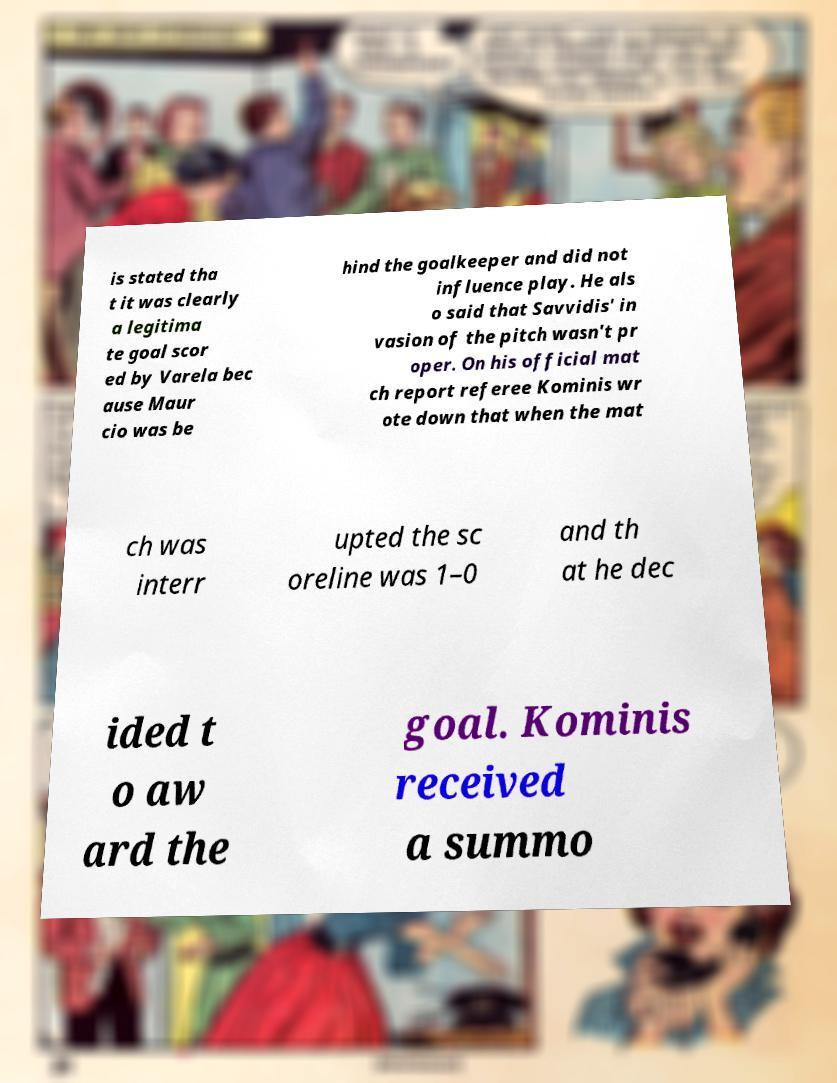What messages or text are displayed in this image? I need them in a readable, typed format. is stated tha t it was clearly a legitima te goal scor ed by Varela bec ause Maur cio was be hind the goalkeeper and did not influence play. He als o said that Savvidis' in vasion of the pitch wasn't pr oper. On his official mat ch report referee Kominis wr ote down that when the mat ch was interr upted the sc oreline was 1–0 and th at he dec ided t o aw ard the goal. Kominis received a summo 